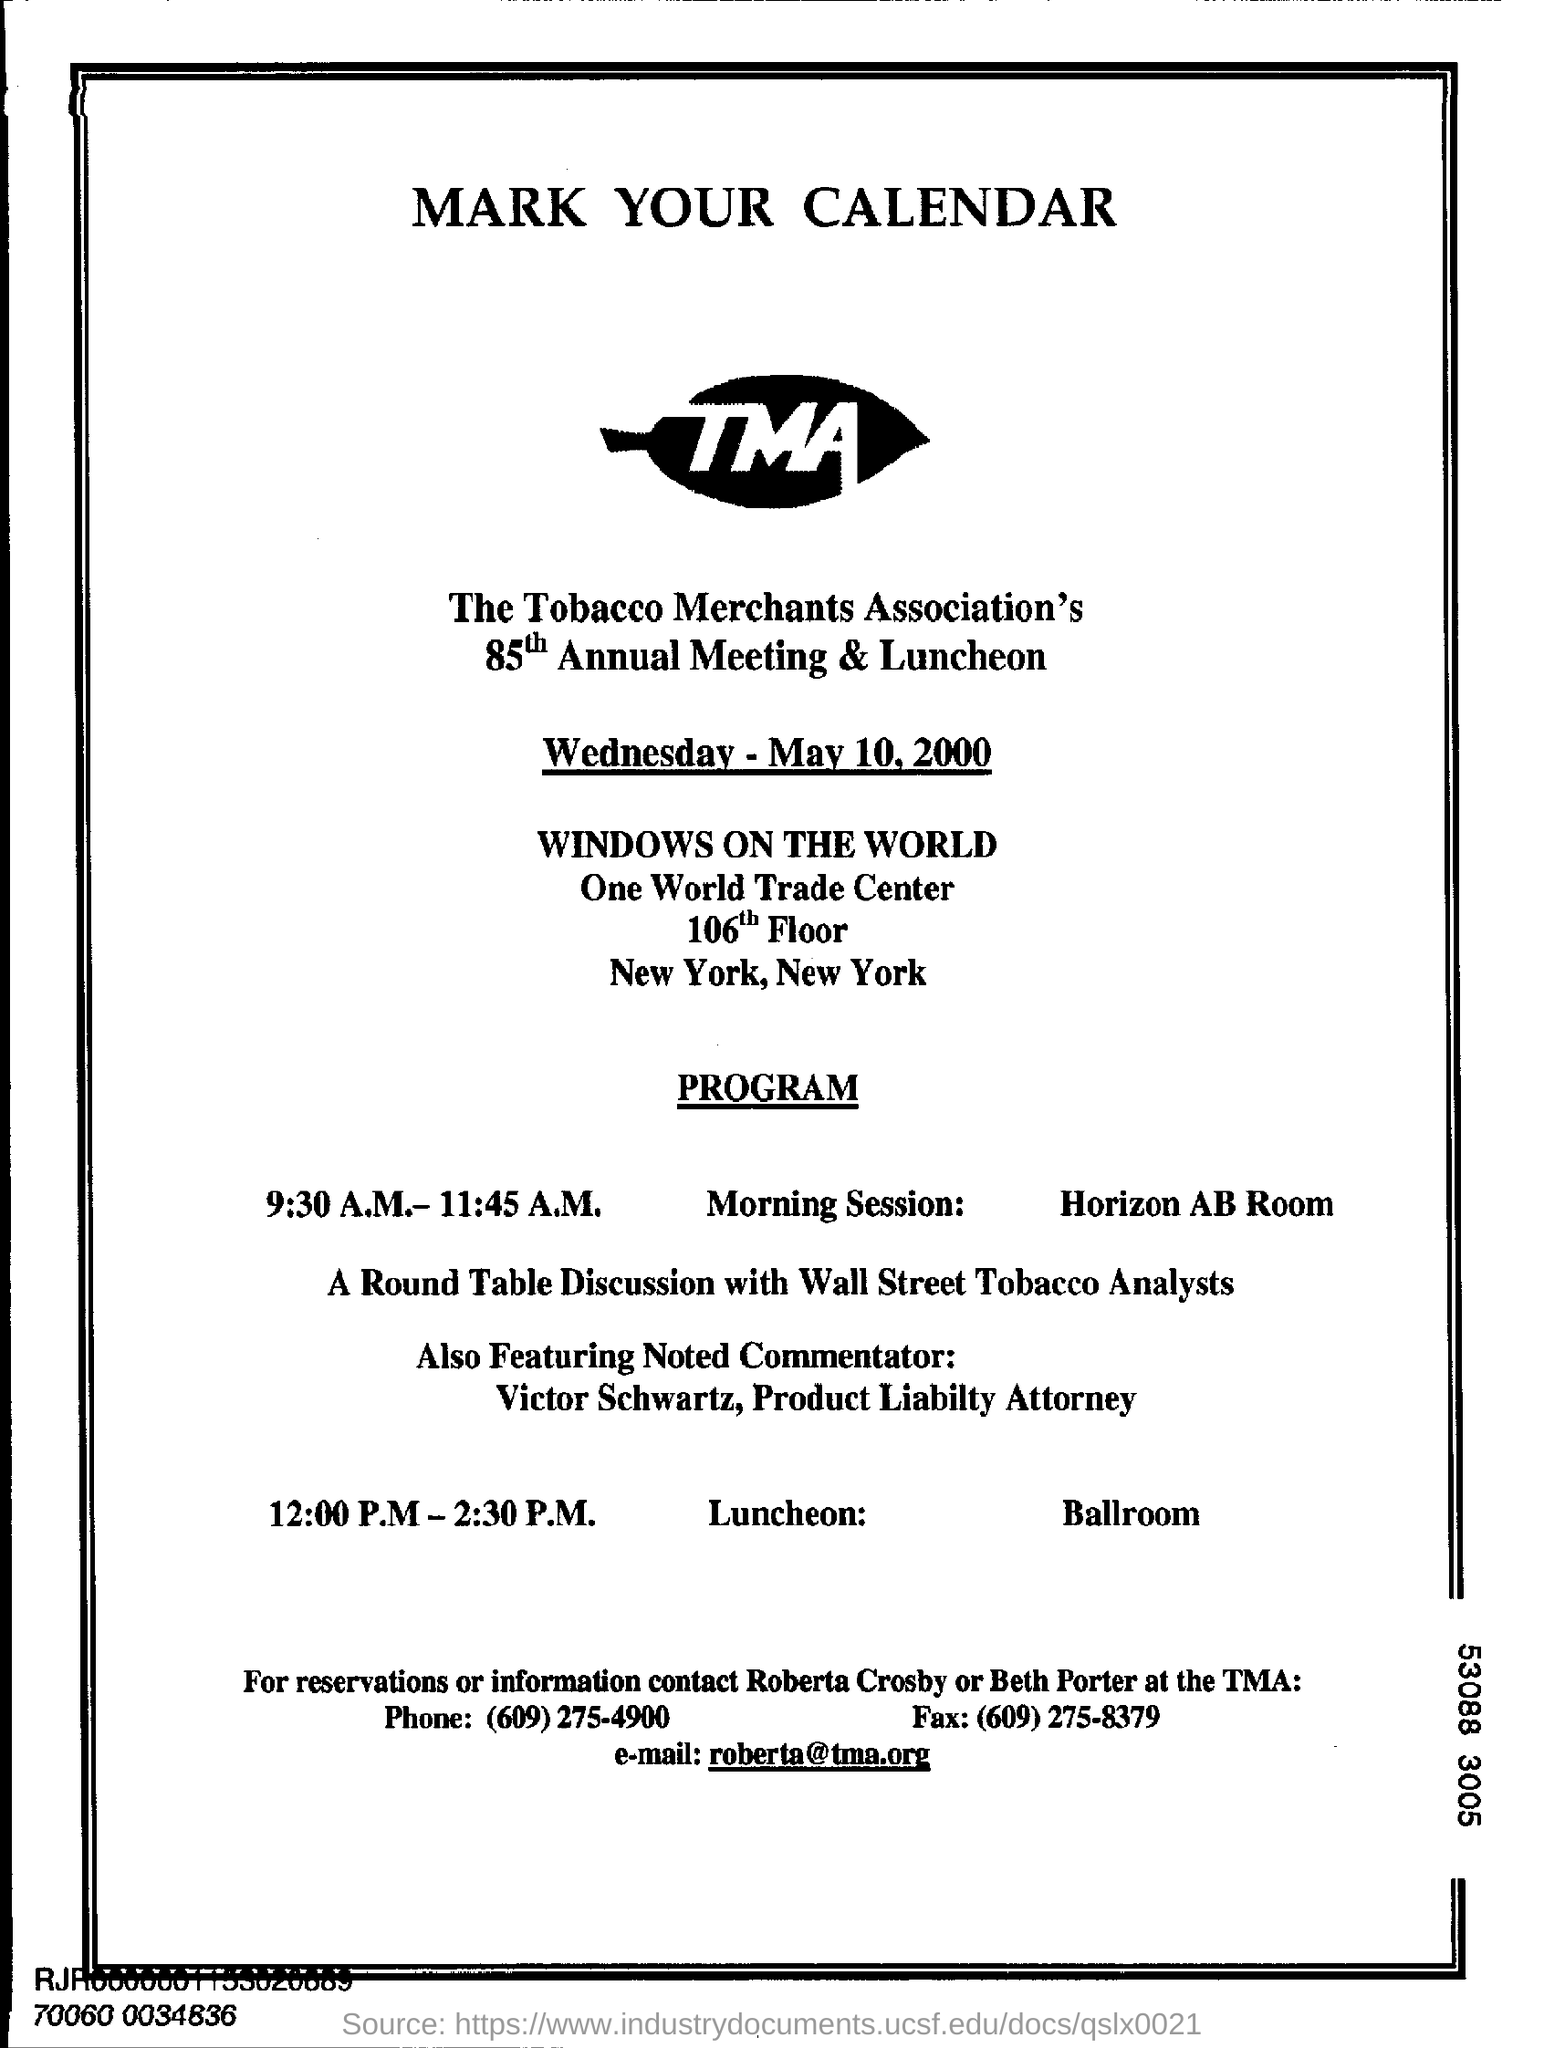What is the full form of (tma)?
Your answer should be very brief. Tobacco merchants association. 